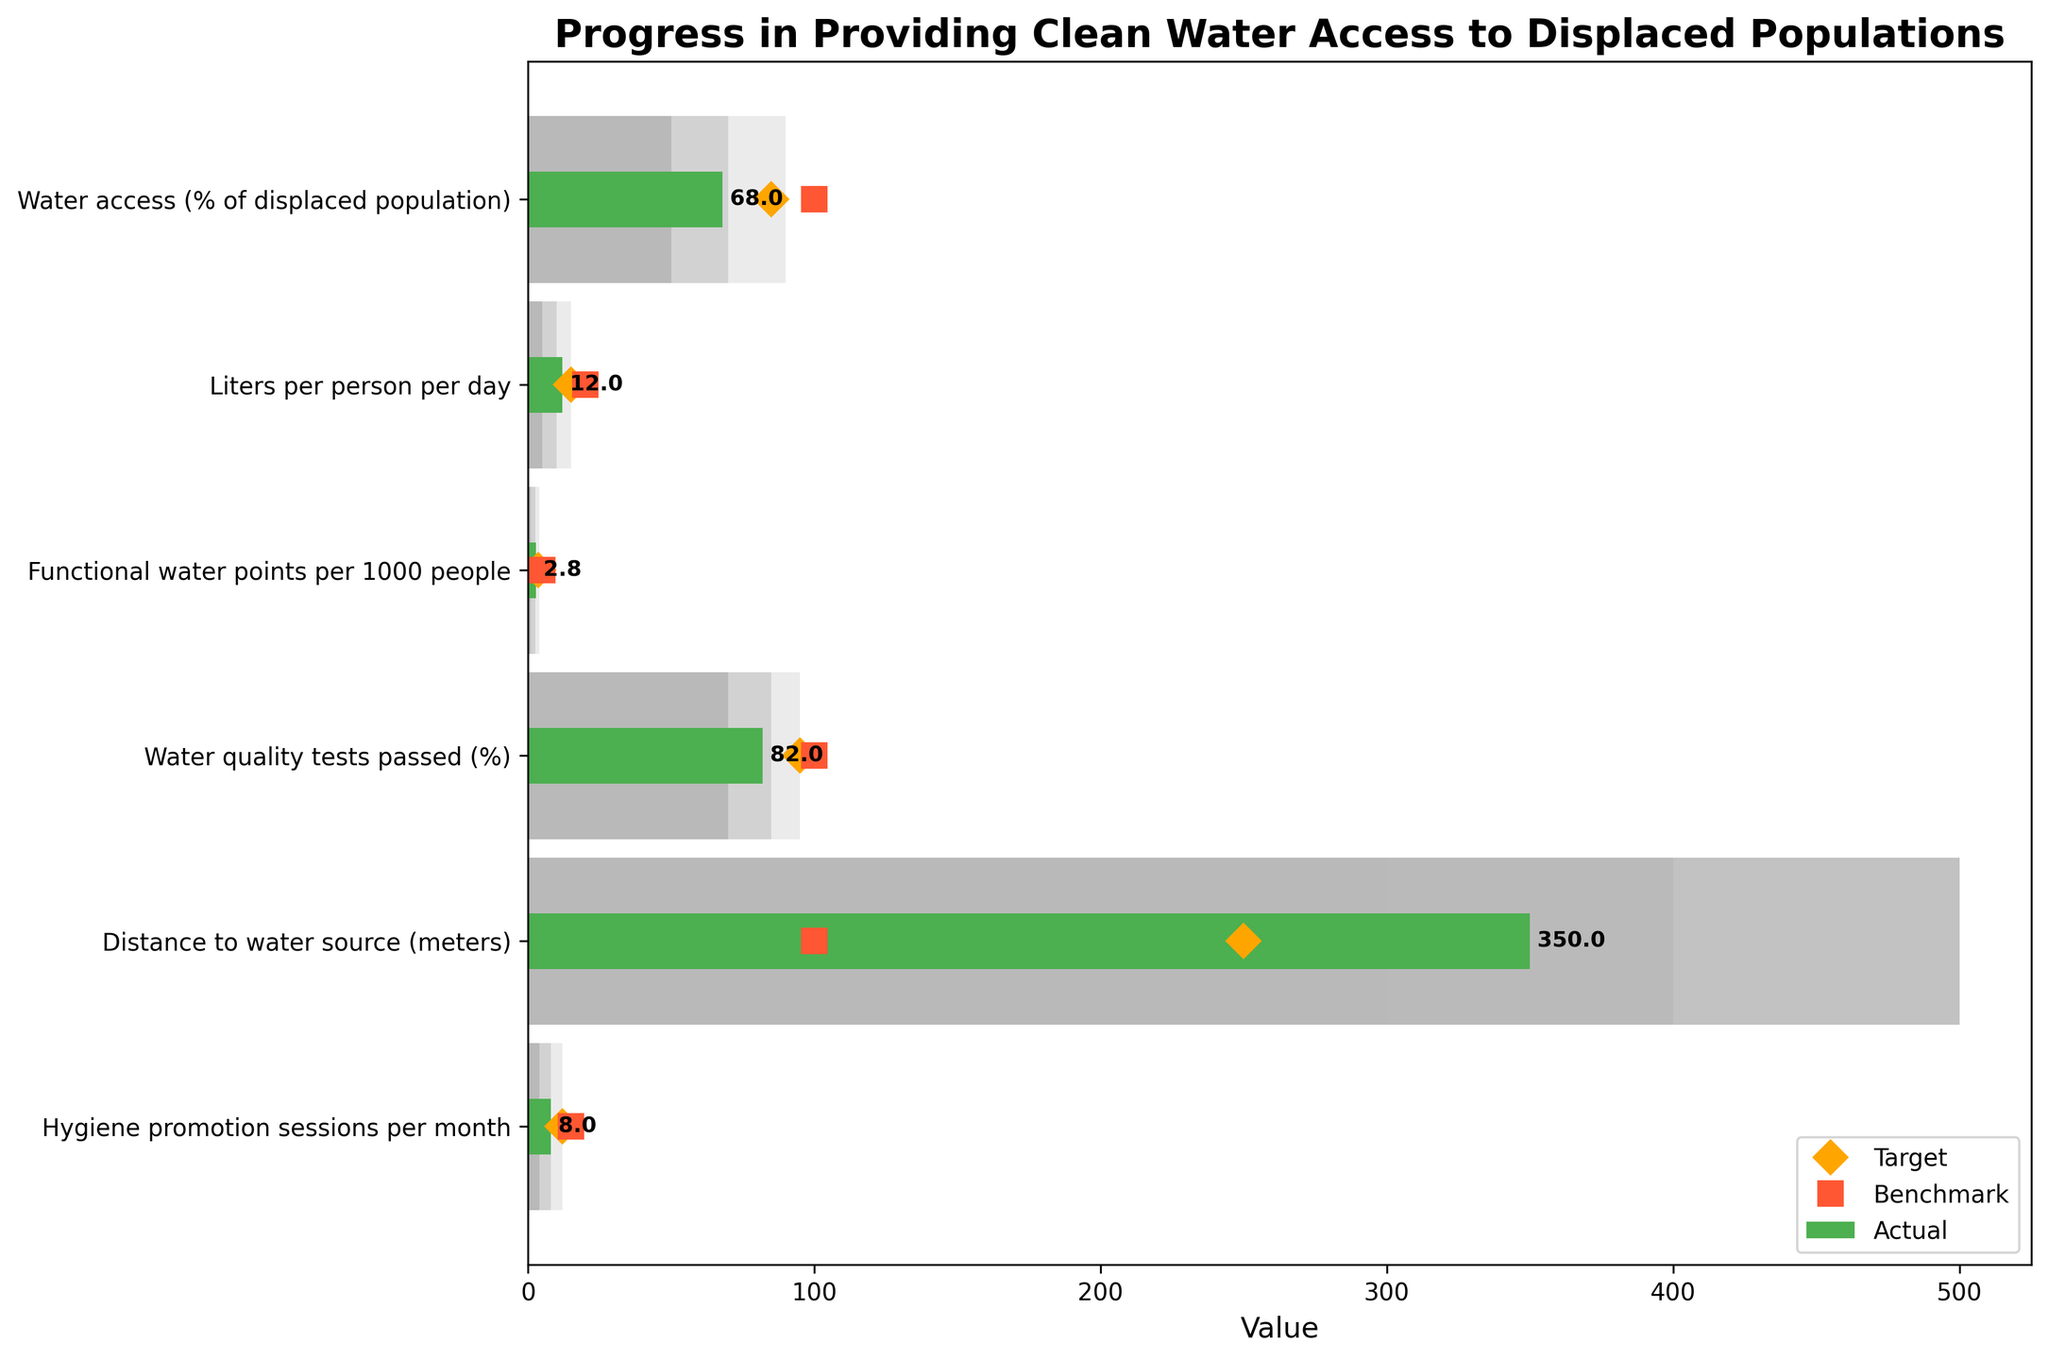What is the title of the chart? The title of the chart is at the top, which usually indicates what the chart is about.
Answer: Progress in Providing Clean Water Access to Displaced Populations What is the actual value for Water access (% of displaced population)? The actual value can be seen by looking at the green bar corresponding to "Water access (% of displaced population)" on the y-axis.
Answer: 68 How many hygiene promotion sessions per month are targeted? The target values are marked by orange diamonds on the chart. For "Hygiene promotion sessions per month," find the orange diamond.
Answer: 12 What is the difference between the actual and target values for Liters per person per day? To find the difference, subtract the actual value from the target value for "Liters per person per day." Actual value: 12, Target: 15. Therefore, 15 - 12.
Answer: 3 Which metric has the highest benchmark value? The benchmark values are represented by red squares. By comparing the red squares for all metrics, we see which one is the highest.
Answer: Water access (% of displaced population) How does water quality tests passed (%) compare to its benchmark? Compare the actual value (green bar) with the benchmark value (red square) for "Water quality tests passed (%)". Actual: 82, Benchmark: 100.
Answer: Below benchmark What is the range for the ‘Medium’ category in Functional water points per 1000 people? The ‘Medium’ category range is shown by the bars in a lighter shade compared to the ‘High’ and ‘Low’ categories. For "Functional water points per 1000 people," check the leftmost and rightmost ends of the ‘Medium’ bar.
Answer: 2.5-4 Which metric shows the largest  gap between actual and benchmark values? Calculate the gaps for each metric by subtracting the actual value from the benchmark value, then compare to find the largest.
Answer: Liters per person per day Does the actual value for Distance to water source (meters) fall within the acceptable 'High' range? The ‘High’ category is shown by the lightest shaded bars. Check if the actual value falls within this range by comparing it to the range of the 'High' bar. Actual: 350, High: 300.
Answer: No What are the three different background bar colors used to represent on this chart? The three different colors are used to represent various categories on the chart, generally light, medium, and dark shades.
Answer: Low, Medium, High 